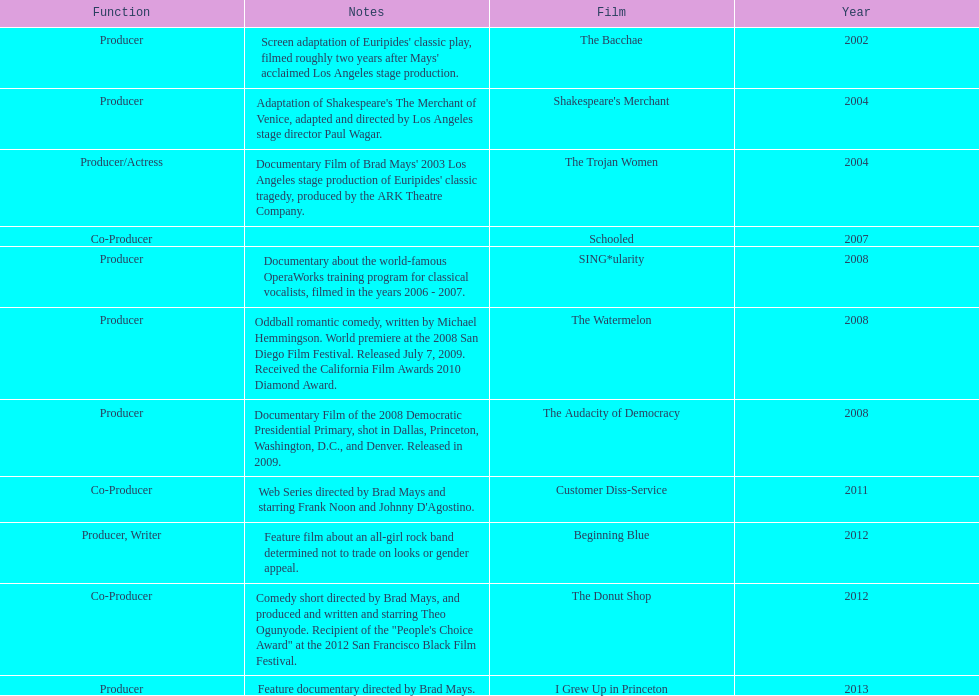Which year was there at least three movies? 2008. 